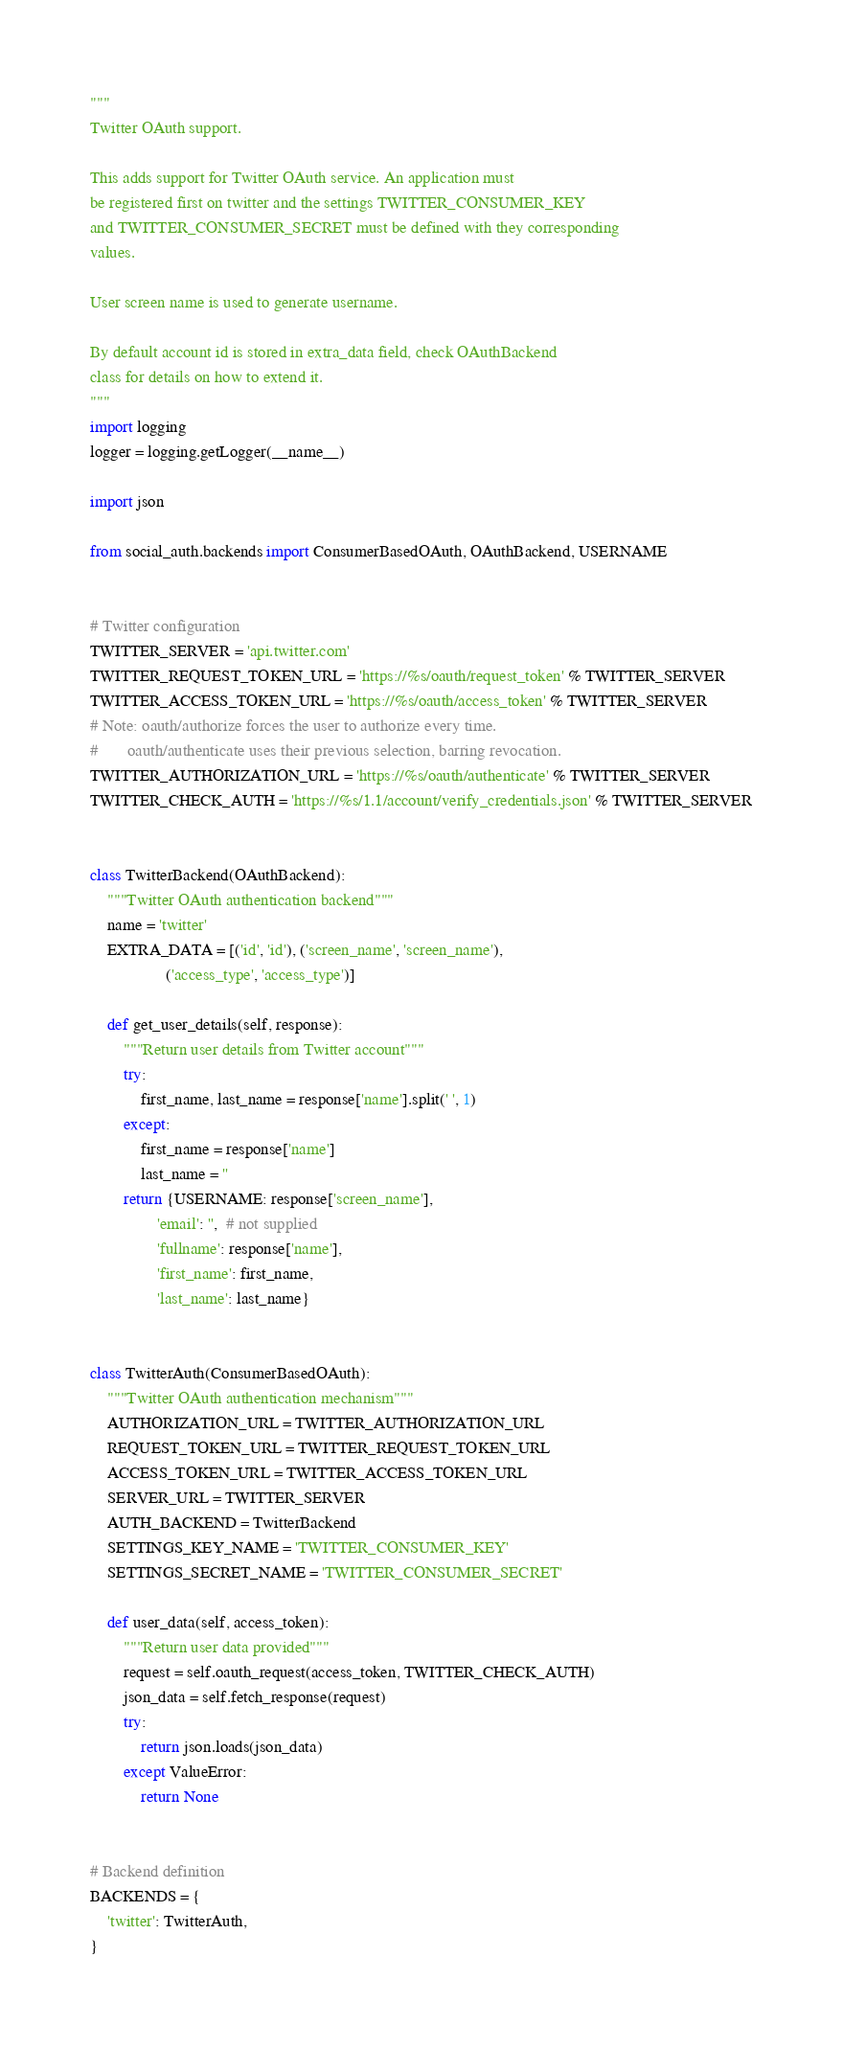<code> <loc_0><loc_0><loc_500><loc_500><_Python_>"""
Twitter OAuth support.

This adds support for Twitter OAuth service. An application must
be registered first on twitter and the settings TWITTER_CONSUMER_KEY
and TWITTER_CONSUMER_SECRET must be defined with they corresponding
values.

User screen name is used to generate username.

By default account id is stored in extra_data field, check OAuthBackend
class for details on how to extend it.
"""
import logging
logger = logging.getLogger(__name__)

import json

from social_auth.backends import ConsumerBasedOAuth, OAuthBackend, USERNAME


# Twitter configuration
TWITTER_SERVER = 'api.twitter.com'
TWITTER_REQUEST_TOKEN_URL = 'https://%s/oauth/request_token' % TWITTER_SERVER
TWITTER_ACCESS_TOKEN_URL = 'https://%s/oauth/access_token' % TWITTER_SERVER
# Note: oauth/authorize forces the user to authorize every time.
#       oauth/authenticate uses their previous selection, barring revocation.
TWITTER_AUTHORIZATION_URL = 'https://%s/oauth/authenticate' % TWITTER_SERVER
TWITTER_CHECK_AUTH = 'https://%s/1.1/account/verify_credentials.json' % TWITTER_SERVER


class TwitterBackend(OAuthBackend):
    """Twitter OAuth authentication backend"""
    name = 'twitter'
    EXTRA_DATA = [('id', 'id'), ('screen_name', 'screen_name'),
                  ('access_type', 'access_type')]

    def get_user_details(self, response):
        """Return user details from Twitter account"""
        try:
            first_name, last_name = response['name'].split(' ', 1)
        except:
            first_name = response['name']
            last_name = ''
        return {USERNAME: response['screen_name'],
                'email': '',  # not supplied
                'fullname': response['name'],
                'first_name': first_name,
                'last_name': last_name}


class TwitterAuth(ConsumerBasedOAuth):
    """Twitter OAuth authentication mechanism"""
    AUTHORIZATION_URL = TWITTER_AUTHORIZATION_URL
    REQUEST_TOKEN_URL = TWITTER_REQUEST_TOKEN_URL
    ACCESS_TOKEN_URL = TWITTER_ACCESS_TOKEN_URL
    SERVER_URL = TWITTER_SERVER
    AUTH_BACKEND = TwitterBackend
    SETTINGS_KEY_NAME = 'TWITTER_CONSUMER_KEY'
    SETTINGS_SECRET_NAME = 'TWITTER_CONSUMER_SECRET'

    def user_data(self, access_token):
        """Return user data provided"""
        request = self.oauth_request(access_token, TWITTER_CHECK_AUTH)
        json_data = self.fetch_response(request)
        try:
            return json.loads(json_data)
        except ValueError:
            return None


# Backend definition
BACKENDS = {
    'twitter': TwitterAuth,
}
</code> 